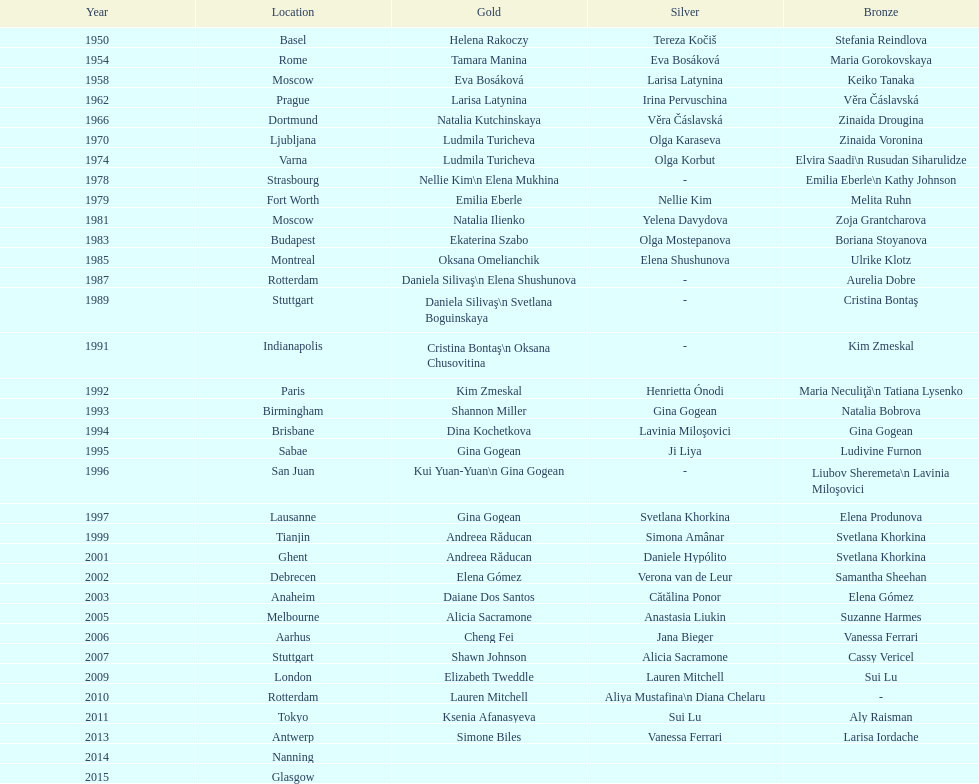What is the total number of russian gymnasts that have won silver. 8. 